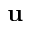Convert formula to latex. <formula><loc_0><loc_0><loc_500><loc_500>{ u }</formula> 